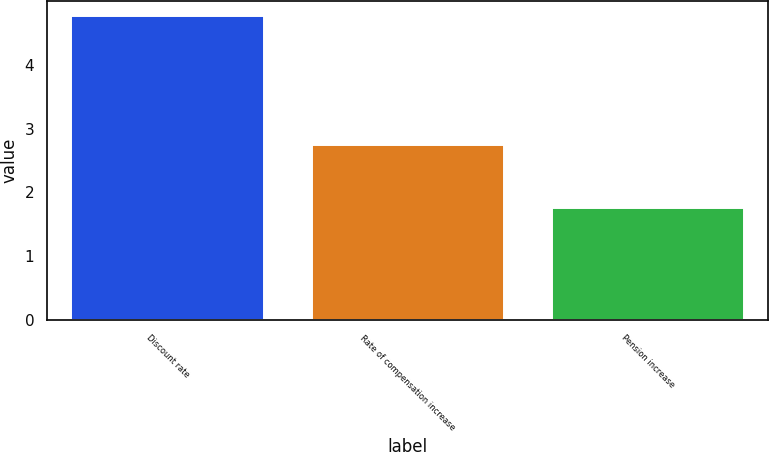Convert chart to OTSL. <chart><loc_0><loc_0><loc_500><loc_500><bar_chart><fcel>Discount rate<fcel>Rate of compensation increase<fcel>Pension increase<nl><fcel>4.76<fcel>2.75<fcel>1.75<nl></chart> 